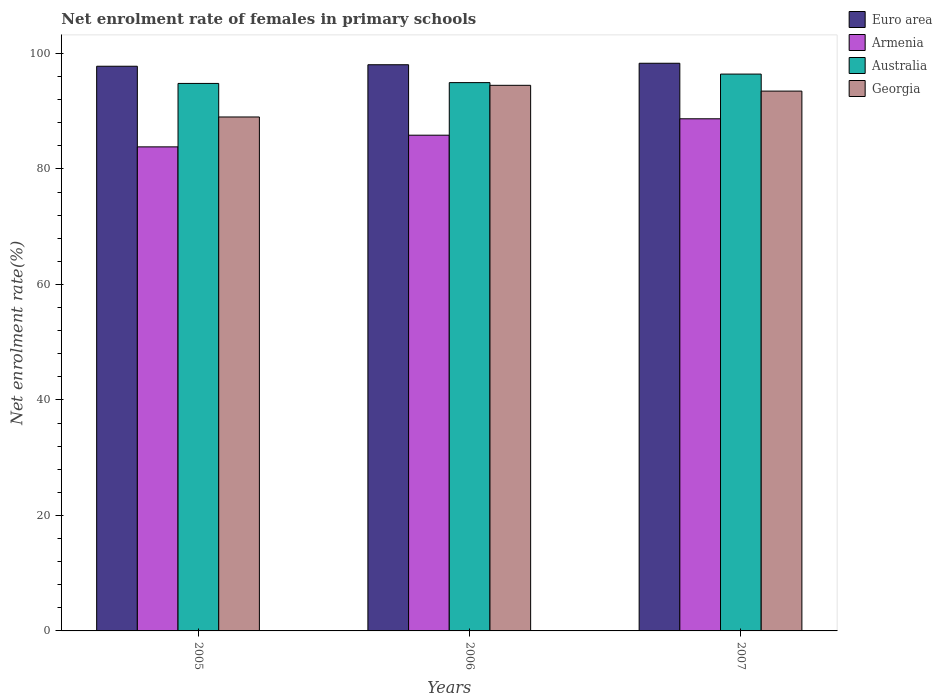How many different coloured bars are there?
Make the answer very short. 4. How many bars are there on the 2nd tick from the right?
Provide a short and direct response. 4. What is the label of the 3rd group of bars from the left?
Your response must be concise. 2007. In how many cases, is the number of bars for a given year not equal to the number of legend labels?
Provide a succinct answer. 0. What is the net enrolment rate of females in primary schools in Euro area in 2005?
Give a very brief answer. 97.78. Across all years, what is the maximum net enrolment rate of females in primary schools in Euro area?
Keep it short and to the point. 98.3. Across all years, what is the minimum net enrolment rate of females in primary schools in Georgia?
Offer a terse response. 89. In which year was the net enrolment rate of females in primary schools in Euro area maximum?
Keep it short and to the point. 2007. What is the total net enrolment rate of females in primary schools in Euro area in the graph?
Offer a terse response. 294.13. What is the difference between the net enrolment rate of females in primary schools in Australia in 2005 and that in 2007?
Offer a terse response. -1.62. What is the difference between the net enrolment rate of females in primary schools in Australia in 2005 and the net enrolment rate of females in primary schools in Georgia in 2006?
Your answer should be very brief. 0.33. What is the average net enrolment rate of females in primary schools in Euro area per year?
Your answer should be very brief. 98.04. In the year 2006, what is the difference between the net enrolment rate of females in primary schools in Georgia and net enrolment rate of females in primary schools in Armenia?
Offer a very short reply. 8.64. In how many years, is the net enrolment rate of females in primary schools in Euro area greater than 72 %?
Offer a very short reply. 3. What is the ratio of the net enrolment rate of females in primary schools in Australia in 2005 to that in 2007?
Make the answer very short. 0.98. Is the difference between the net enrolment rate of females in primary schools in Georgia in 2005 and 2007 greater than the difference between the net enrolment rate of females in primary schools in Armenia in 2005 and 2007?
Provide a short and direct response. Yes. What is the difference between the highest and the second highest net enrolment rate of females in primary schools in Georgia?
Give a very brief answer. 1. What is the difference between the highest and the lowest net enrolment rate of females in primary schools in Euro area?
Offer a terse response. 0.52. In how many years, is the net enrolment rate of females in primary schools in Georgia greater than the average net enrolment rate of females in primary schools in Georgia taken over all years?
Give a very brief answer. 2. What does the 3rd bar from the right in 2005 represents?
Provide a succinct answer. Armenia. Is it the case that in every year, the sum of the net enrolment rate of females in primary schools in Australia and net enrolment rate of females in primary schools in Georgia is greater than the net enrolment rate of females in primary schools in Euro area?
Make the answer very short. Yes. How many bars are there?
Your response must be concise. 12. Are all the bars in the graph horizontal?
Your answer should be compact. No. What is the difference between two consecutive major ticks on the Y-axis?
Offer a terse response. 20. Are the values on the major ticks of Y-axis written in scientific E-notation?
Your answer should be compact. No. Does the graph contain grids?
Ensure brevity in your answer.  No. Where does the legend appear in the graph?
Offer a terse response. Top right. What is the title of the graph?
Offer a very short reply. Net enrolment rate of females in primary schools. Does "Latin America(developing only)" appear as one of the legend labels in the graph?
Your answer should be compact. No. What is the label or title of the Y-axis?
Provide a short and direct response. Net enrolment rate(%). What is the Net enrolment rate(%) of Euro area in 2005?
Make the answer very short. 97.78. What is the Net enrolment rate(%) of Armenia in 2005?
Provide a succinct answer. 83.82. What is the Net enrolment rate(%) of Australia in 2005?
Your answer should be compact. 94.81. What is the Net enrolment rate(%) in Georgia in 2005?
Offer a terse response. 89. What is the Net enrolment rate(%) of Euro area in 2006?
Provide a succinct answer. 98.04. What is the Net enrolment rate(%) in Armenia in 2006?
Give a very brief answer. 85.84. What is the Net enrolment rate(%) in Australia in 2006?
Offer a terse response. 94.95. What is the Net enrolment rate(%) of Georgia in 2006?
Ensure brevity in your answer.  94.48. What is the Net enrolment rate(%) of Euro area in 2007?
Provide a succinct answer. 98.3. What is the Net enrolment rate(%) in Armenia in 2007?
Ensure brevity in your answer.  88.69. What is the Net enrolment rate(%) in Australia in 2007?
Provide a short and direct response. 96.43. What is the Net enrolment rate(%) in Georgia in 2007?
Provide a short and direct response. 93.48. Across all years, what is the maximum Net enrolment rate(%) in Euro area?
Offer a terse response. 98.3. Across all years, what is the maximum Net enrolment rate(%) in Armenia?
Offer a terse response. 88.69. Across all years, what is the maximum Net enrolment rate(%) of Australia?
Offer a very short reply. 96.43. Across all years, what is the maximum Net enrolment rate(%) in Georgia?
Offer a very short reply. 94.48. Across all years, what is the minimum Net enrolment rate(%) of Euro area?
Offer a very short reply. 97.78. Across all years, what is the minimum Net enrolment rate(%) in Armenia?
Your response must be concise. 83.82. Across all years, what is the minimum Net enrolment rate(%) of Australia?
Your response must be concise. 94.81. Across all years, what is the minimum Net enrolment rate(%) in Georgia?
Make the answer very short. 89. What is the total Net enrolment rate(%) of Euro area in the graph?
Your answer should be compact. 294.13. What is the total Net enrolment rate(%) of Armenia in the graph?
Provide a short and direct response. 258.35. What is the total Net enrolment rate(%) in Australia in the graph?
Provide a succinct answer. 286.18. What is the total Net enrolment rate(%) of Georgia in the graph?
Your response must be concise. 276.96. What is the difference between the Net enrolment rate(%) in Euro area in 2005 and that in 2006?
Give a very brief answer. -0.26. What is the difference between the Net enrolment rate(%) in Armenia in 2005 and that in 2006?
Your answer should be very brief. -2.02. What is the difference between the Net enrolment rate(%) in Australia in 2005 and that in 2006?
Make the answer very short. -0.14. What is the difference between the Net enrolment rate(%) in Georgia in 2005 and that in 2006?
Provide a succinct answer. -5.48. What is the difference between the Net enrolment rate(%) of Euro area in 2005 and that in 2007?
Keep it short and to the point. -0.52. What is the difference between the Net enrolment rate(%) in Armenia in 2005 and that in 2007?
Ensure brevity in your answer.  -4.86. What is the difference between the Net enrolment rate(%) of Australia in 2005 and that in 2007?
Offer a very short reply. -1.62. What is the difference between the Net enrolment rate(%) of Georgia in 2005 and that in 2007?
Keep it short and to the point. -4.48. What is the difference between the Net enrolment rate(%) in Euro area in 2006 and that in 2007?
Keep it short and to the point. -0.26. What is the difference between the Net enrolment rate(%) in Armenia in 2006 and that in 2007?
Your response must be concise. -2.84. What is the difference between the Net enrolment rate(%) in Australia in 2006 and that in 2007?
Make the answer very short. -1.48. What is the difference between the Net enrolment rate(%) in Georgia in 2006 and that in 2007?
Offer a very short reply. 1. What is the difference between the Net enrolment rate(%) of Euro area in 2005 and the Net enrolment rate(%) of Armenia in 2006?
Provide a succinct answer. 11.94. What is the difference between the Net enrolment rate(%) of Euro area in 2005 and the Net enrolment rate(%) of Australia in 2006?
Provide a short and direct response. 2.84. What is the difference between the Net enrolment rate(%) of Euro area in 2005 and the Net enrolment rate(%) of Georgia in 2006?
Keep it short and to the point. 3.3. What is the difference between the Net enrolment rate(%) in Armenia in 2005 and the Net enrolment rate(%) in Australia in 2006?
Make the answer very short. -11.13. What is the difference between the Net enrolment rate(%) of Armenia in 2005 and the Net enrolment rate(%) of Georgia in 2006?
Provide a short and direct response. -10.66. What is the difference between the Net enrolment rate(%) of Australia in 2005 and the Net enrolment rate(%) of Georgia in 2006?
Offer a terse response. 0.33. What is the difference between the Net enrolment rate(%) in Euro area in 2005 and the Net enrolment rate(%) in Armenia in 2007?
Keep it short and to the point. 9.1. What is the difference between the Net enrolment rate(%) of Euro area in 2005 and the Net enrolment rate(%) of Australia in 2007?
Keep it short and to the point. 1.36. What is the difference between the Net enrolment rate(%) in Euro area in 2005 and the Net enrolment rate(%) in Georgia in 2007?
Offer a terse response. 4.3. What is the difference between the Net enrolment rate(%) in Armenia in 2005 and the Net enrolment rate(%) in Australia in 2007?
Offer a terse response. -12.6. What is the difference between the Net enrolment rate(%) of Armenia in 2005 and the Net enrolment rate(%) of Georgia in 2007?
Make the answer very short. -9.66. What is the difference between the Net enrolment rate(%) in Australia in 2005 and the Net enrolment rate(%) in Georgia in 2007?
Keep it short and to the point. 1.33. What is the difference between the Net enrolment rate(%) of Euro area in 2006 and the Net enrolment rate(%) of Armenia in 2007?
Provide a short and direct response. 9.36. What is the difference between the Net enrolment rate(%) of Euro area in 2006 and the Net enrolment rate(%) of Australia in 2007?
Your answer should be very brief. 1.62. What is the difference between the Net enrolment rate(%) in Euro area in 2006 and the Net enrolment rate(%) in Georgia in 2007?
Offer a terse response. 4.56. What is the difference between the Net enrolment rate(%) of Armenia in 2006 and the Net enrolment rate(%) of Australia in 2007?
Make the answer very short. -10.58. What is the difference between the Net enrolment rate(%) of Armenia in 2006 and the Net enrolment rate(%) of Georgia in 2007?
Your answer should be very brief. -7.64. What is the difference between the Net enrolment rate(%) in Australia in 2006 and the Net enrolment rate(%) in Georgia in 2007?
Your answer should be compact. 1.47. What is the average Net enrolment rate(%) in Euro area per year?
Provide a succinct answer. 98.04. What is the average Net enrolment rate(%) of Armenia per year?
Your response must be concise. 86.12. What is the average Net enrolment rate(%) in Australia per year?
Offer a terse response. 95.39. What is the average Net enrolment rate(%) in Georgia per year?
Provide a short and direct response. 92.32. In the year 2005, what is the difference between the Net enrolment rate(%) in Euro area and Net enrolment rate(%) in Armenia?
Provide a short and direct response. 13.96. In the year 2005, what is the difference between the Net enrolment rate(%) in Euro area and Net enrolment rate(%) in Australia?
Your answer should be compact. 2.98. In the year 2005, what is the difference between the Net enrolment rate(%) in Euro area and Net enrolment rate(%) in Georgia?
Provide a short and direct response. 8.79. In the year 2005, what is the difference between the Net enrolment rate(%) of Armenia and Net enrolment rate(%) of Australia?
Ensure brevity in your answer.  -10.99. In the year 2005, what is the difference between the Net enrolment rate(%) in Armenia and Net enrolment rate(%) in Georgia?
Your answer should be very brief. -5.18. In the year 2005, what is the difference between the Net enrolment rate(%) in Australia and Net enrolment rate(%) in Georgia?
Make the answer very short. 5.81. In the year 2006, what is the difference between the Net enrolment rate(%) of Euro area and Net enrolment rate(%) of Armenia?
Make the answer very short. 12.2. In the year 2006, what is the difference between the Net enrolment rate(%) in Euro area and Net enrolment rate(%) in Australia?
Provide a short and direct response. 3.1. In the year 2006, what is the difference between the Net enrolment rate(%) of Euro area and Net enrolment rate(%) of Georgia?
Offer a very short reply. 3.56. In the year 2006, what is the difference between the Net enrolment rate(%) in Armenia and Net enrolment rate(%) in Australia?
Provide a short and direct response. -9.1. In the year 2006, what is the difference between the Net enrolment rate(%) of Armenia and Net enrolment rate(%) of Georgia?
Provide a succinct answer. -8.64. In the year 2006, what is the difference between the Net enrolment rate(%) of Australia and Net enrolment rate(%) of Georgia?
Provide a succinct answer. 0.47. In the year 2007, what is the difference between the Net enrolment rate(%) in Euro area and Net enrolment rate(%) in Armenia?
Offer a terse response. 9.61. In the year 2007, what is the difference between the Net enrolment rate(%) in Euro area and Net enrolment rate(%) in Australia?
Give a very brief answer. 1.87. In the year 2007, what is the difference between the Net enrolment rate(%) in Euro area and Net enrolment rate(%) in Georgia?
Provide a short and direct response. 4.82. In the year 2007, what is the difference between the Net enrolment rate(%) of Armenia and Net enrolment rate(%) of Australia?
Provide a short and direct response. -7.74. In the year 2007, what is the difference between the Net enrolment rate(%) of Armenia and Net enrolment rate(%) of Georgia?
Ensure brevity in your answer.  -4.79. In the year 2007, what is the difference between the Net enrolment rate(%) in Australia and Net enrolment rate(%) in Georgia?
Your response must be concise. 2.95. What is the ratio of the Net enrolment rate(%) in Euro area in 2005 to that in 2006?
Your answer should be very brief. 1. What is the ratio of the Net enrolment rate(%) of Armenia in 2005 to that in 2006?
Offer a very short reply. 0.98. What is the ratio of the Net enrolment rate(%) of Australia in 2005 to that in 2006?
Offer a very short reply. 1. What is the ratio of the Net enrolment rate(%) in Georgia in 2005 to that in 2006?
Your answer should be very brief. 0.94. What is the ratio of the Net enrolment rate(%) of Armenia in 2005 to that in 2007?
Your response must be concise. 0.95. What is the ratio of the Net enrolment rate(%) in Australia in 2005 to that in 2007?
Provide a succinct answer. 0.98. What is the ratio of the Net enrolment rate(%) in Georgia in 2005 to that in 2007?
Provide a short and direct response. 0.95. What is the ratio of the Net enrolment rate(%) in Euro area in 2006 to that in 2007?
Your response must be concise. 1. What is the ratio of the Net enrolment rate(%) in Armenia in 2006 to that in 2007?
Offer a very short reply. 0.97. What is the ratio of the Net enrolment rate(%) in Australia in 2006 to that in 2007?
Make the answer very short. 0.98. What is the ratio of the Net enrolment rate(%) in Georgia in 2006 to that in 2007?
Make the answer very short. 1.01. What is the difference between the highest and the second highest Net enrolment rate(%) of Euro area?
Provide a succinct answer. 0.26. What is the difference between the highest and the second highest Net enrolment rate(%) of Armenia?
Your response must be concise. 2.84. What is the difference between the highest and the second highest Net enrolment rate(%) of Australia?
Offer a very short reply. 1.48. What is the difference between the highest and the lowest Net enrolment rate(%) in Euro area?
Offer a terse response. 0.52. What is the difference between the highest and the lowest Net enrolment rate(%) in Armenia?
Ensure brevity in your answer.  4.86. What is the difference between the highest and the lowest Net enrolment rate(%) of Australia?
Give a very brief answer. 1.62. What is the difference between the highest and the lowest Net enrolment rate(%) in Georgia?
Provide a short and direct response. 5.48. 